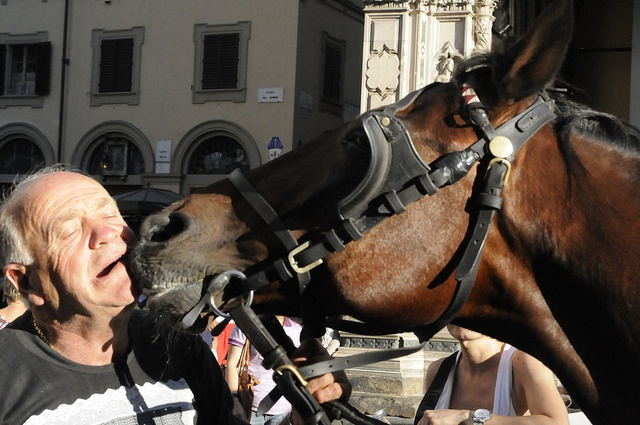Describe the objects in this image and their specific colors. I can see horse in black, maroon, and gray tones, people in black, gray, tan, and ivory tones, people in black, brown, gray, and tan tones, people in black, white, darkgray, and gray tones, and people in black, salmon, white, and tan tones in this image. 